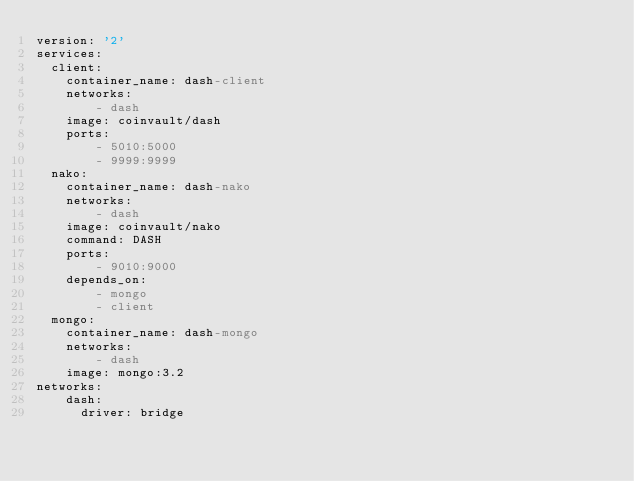<code> <loc_0><loc_0><loc_500><loc_500><_YAML_>version: '2'
services:
  client:
    container_name: dash-client
    networks: 
        - dash
    image: coinvault/dash
    ports: 
        - 5010:5000
        - 9999:9999
  nako:
    container_name: dash-nako
    networks: 
        - dash
    image: coinvault/nako
    command: DASH
    ports: 
        - 9010:9000
    depends_on:
        - mongo
        - client
  mongo:
    container_name: dash-mongo
    networks: 
        - dash
    image: mongo:3.2
networks:
    dash:
      driver: bridge</code> 